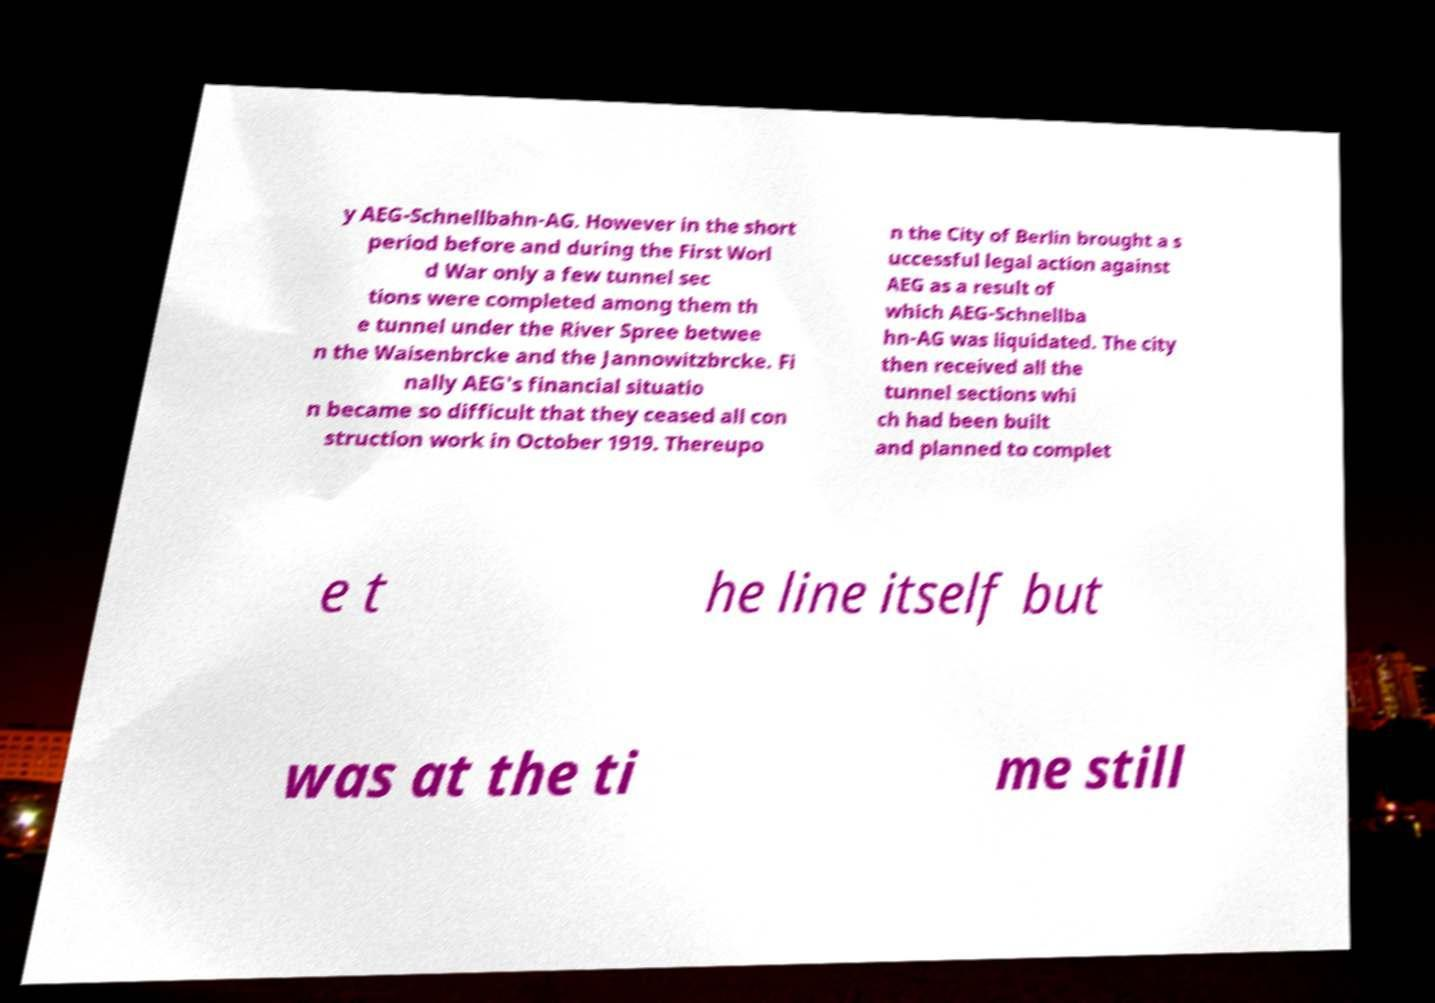Could you assist in decoding the text presented in this image and type it out clearly? y AEG-Schnellbahn-AG. However in the short period before and during the First Worl d War only a few tunnel sec tions were completed among them th e tunnel under the River Spree betwee n the Waisenbrcke and the Jannowitzbrcke. Fi nally AEG's financial situatio n became so difficult that they ceased all con struction work in October 1919. Thereupo n the City of Berlin brought a s uccessful legal action against AEG as a result of which AEG-Schnellba hn-AG was liquidated. The city then received all the tunnel sections whi ch had been built and planned to complet e t he line itself but was at the ti me still 